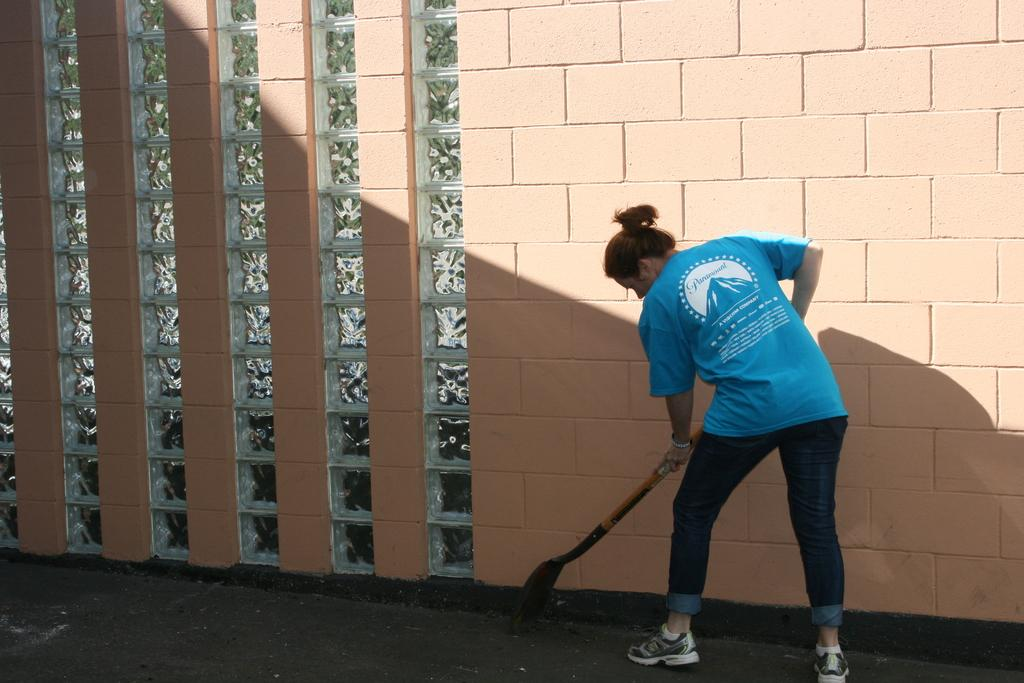What can be seen in the image? There is a person in the image. What is the person holding? The person is holding something, but the facts do not specify what it is. What color is the person's top? The person is wearing a blue top. What type of pants is the person wearing? The person is wearing jeans. What color is the wall in the background? There is a peach-colored wall in the image. What type of substance is the person using to fly in the image? There is no indication in the image that the person is flying or using any substance to do so. 